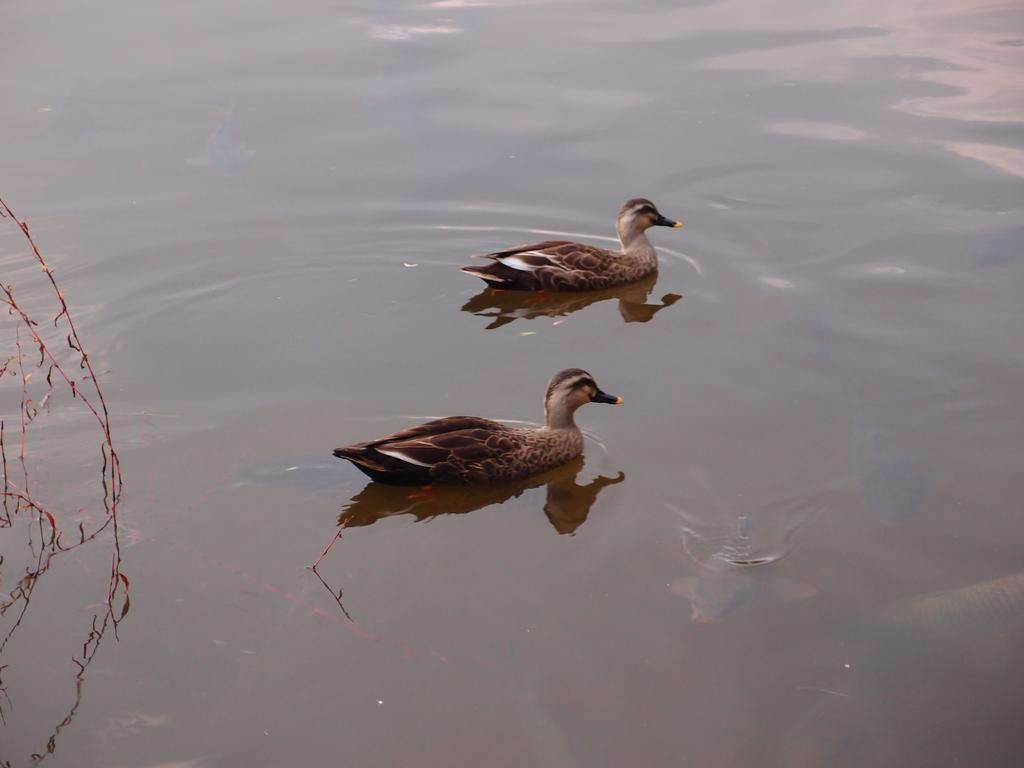How would you summarize this image in a sentence or two? In this picture, we see two ducks are swimming in the water. This water might be in the pond. On the left side, we see the plants. 